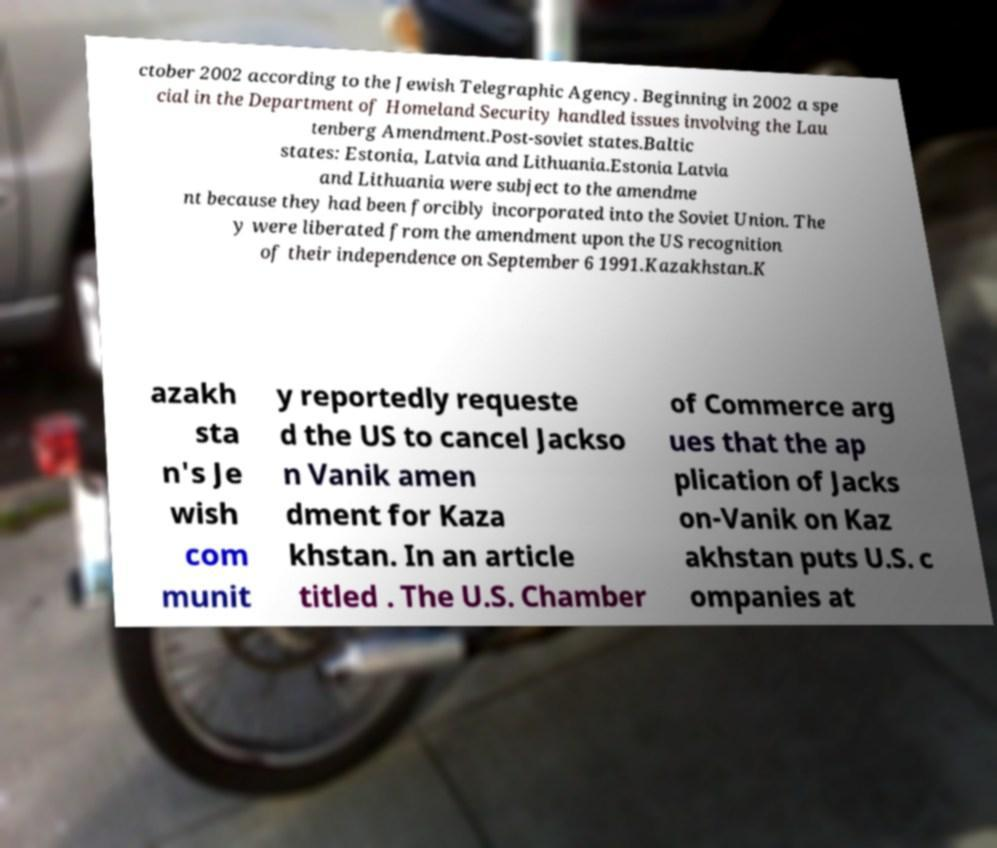Could you extract and type out the text from this image? ctober 2002 according to the Jewish Telegraphic Agency. Beginning in 2002 a spe cial in the Department of Homeland Security handled issues involving the Lau tenberg Amendment.Post-soviet states.Baltic states: Estonia, Latvia and Lithuania.Estonia Latvia and Lithuania were subject to the amendme nt because they had been forcibly incorporated into the Soviet Union. The y were liberated from the amendment upon the US recognition of their independence on September 6 1991.Kazakhstan.K azakh sta n's Je wish com munit y reportedly requeste d the US to cancel Jackso n Vanik amen dment for Kaza khstan. In an article titled . The U.S. Chamber of Commerce arg ues that the ap plication of Jacks on-Vanik on Kaz akhstan puts U.S. c ompanies at 